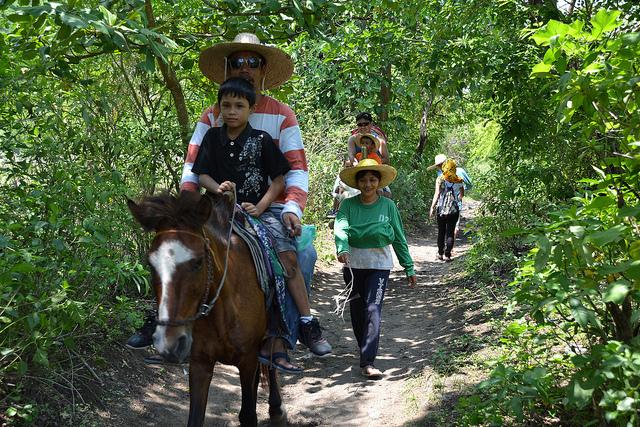What is on the people's heads?
Short answer required. Hats. Why is the woman smiling?
Short answer required. Happy. How many people are riding an animal?
Give a very brief answer. 2. Are they Mexicans?
Give a very brief answer. Yes. 